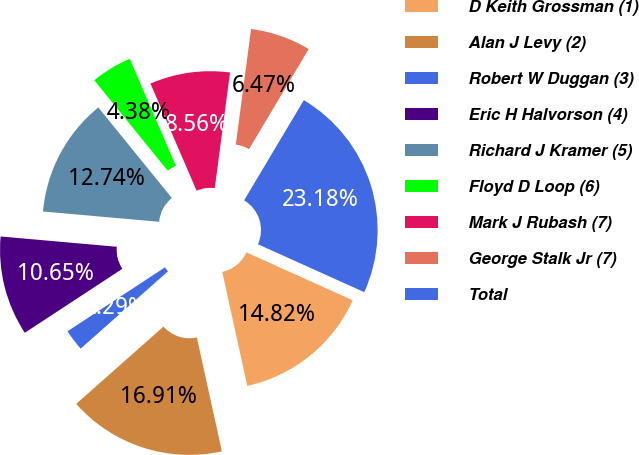<chart> <loc_0><loc_0><loc_500><loc_500><pie_chart><fcel>D Keith Grossman (1)<fcel>Alan J Levy (2)<fcel>Robert W Duggan (3)<fcel>Eric H Halvorson (4)<fcel>Richard J Kramer (5)<fcel>Floyd D Loop (6)<fcel>Mark J Rubash (7)<fcel>George Stalk Jr (7)<fcel>Total<nl><fcel>14.82%<fcel>16.91%<fcel>2.29%<fcel>10.65%<fcel>12.74%<fcel>4.38%<fcel>8.56%<fcel>6.47%<fcel>23.18%<nl></chart> 